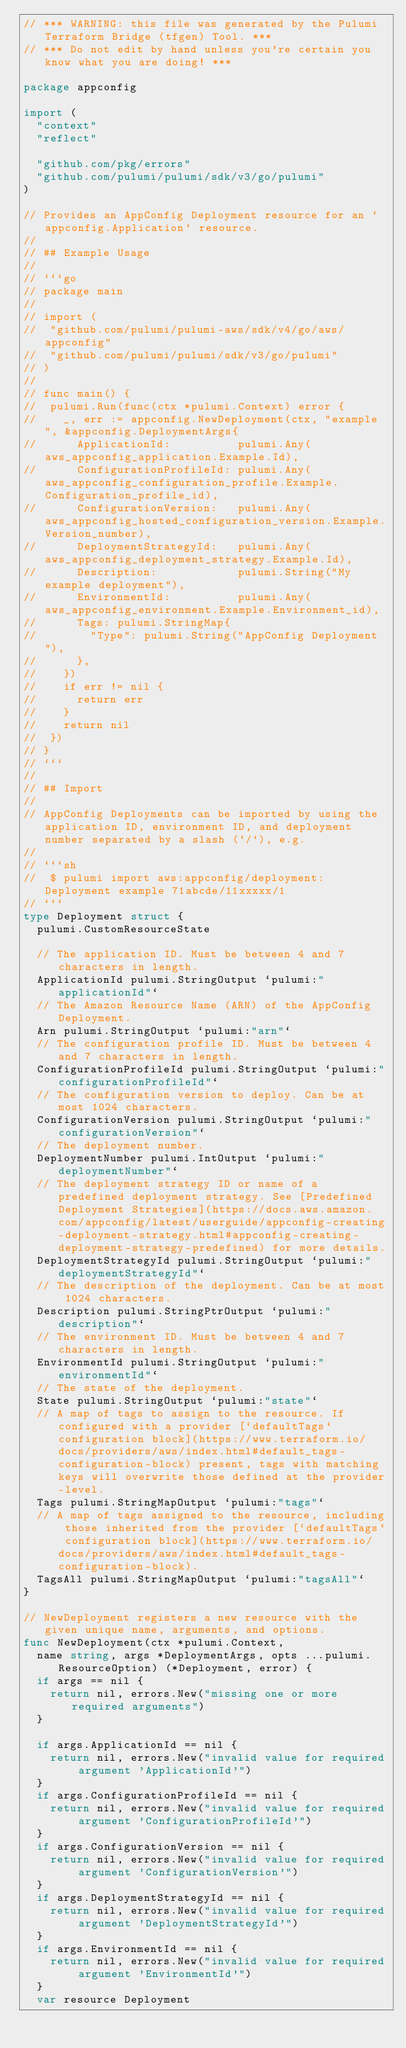Convert code to text. <code><loc_0><loc_0><loc_500><loc_500><_Go_>// *** WARNING: this file was generated by the Pulumi Terraform Bridge (tfgen) Tool. ***
// *** Do not edit by hand unless you're certain you know what you are doing! ***

package appconfig

import (
	"context"
	"reflect"

	"github.com/pkg/errors"
	"github.com/pulumi/pulumi/sdk/v3/go/pulumi"
)

// Provides an AppConfig Deployment resource for an `appconfig.Application` resource.
//
// ## Example Usage
//
// ```go
// package main
//
// import (
// 	"github.com/pulumi/pulumi-aws/sdk/v4/go/aws/appconfig"
// 	"github.com/pulumi/pulumi/sdk/v3/go/pulumi"
// )
//
// func main() {
// 	pulumi.Run(func(ctx *pulumi.Context) error {
// 		_, err := appconfig.NewDeployment(ctx, "example", &appconfig.DeploymentArgs{
// 			ApplicationId:          pulumi.Any(aws_appconfig_application.Example.Id),
// 			ConfigurationProfileId: pulumi.Any(aws_appconfig_configuration_profile.Example.Configuration_profile_id),
// 			ConfigurationVersion:   pulumi.Any(aws_appconfig_hosted_configuration_version.Example.Version_number),
// 			DeploymentStrategyId:   pulumi.Any(aws_appconfig_deployment_strategy.Example.Id),
// 			Description:            pulumi.String("My example deployment"),
// 			EnvironmentId:          pulumi.Any(aws_appconfig_environment.Example.Environment_id),
// 			Tags: pulumi.StringMap{
// 				"Type": pulumi.String("AppConfig Deployment"),
// 			},
// 		})
// 		if err != nil {
// 			return err
// 		}
// 		return nil
// 	})
// }
// ```
//
// ## Import
//
// AppConfig Deployments can be imported by using the application ID, environment ID, and deployment number separated by a slash (`/`), e.g.
//
// ```sh
//  $ pulumi import aws:appconfig/deployment:Deployment example 71abcde/11xxxxx/1
// ```
type Deployment struct {
	pulumi.CustomResourceState

	// The application ID. Must be between 4 and 7 characters in length.
	ApplicationId pulumi.StringOutput `pulumi:"applicationId"`
	// The Amazon Resource Name (ARN) of the AppConfig Deployment.
	Arn pulumi.StringOutput `pulumi:"arn"`
	// The configuration profile ID. Must be between 4 and 7 characters in length.
	ConfigurationProfileId pulumi.StringOutput `pulumi:"configurationProfileId"`
	// The configuration version to deploy. Can be at most 1024 characters.
	ConfigurationVersion pulumi.StringOutput `pulumi:"configurationVersion"`
	// The deployment number.
	DeploymentNumber pulumi.IntOutput `pulumi:"deploymentNumber"`
	// The deployment strategy ID or name of a predefined deployment strategy. See [Predefined Deployment Strategies](https://docs.aws.amazon.com/appconfig/latest/userguide/appconfig-creating-deployment-strategy.html#appconfig-creating-deployment-strategy-predefined) for more details.
	DeploymentStrategyId pulumi.StringOutput `pulumi:"deploymentStrategyId"`
	// The description of the deployment. Can be at most 1024 characters.
	Description pulumi.StringPtrOutput `pulumi:"description"`
	// The environment ID. Must be between 4 and 7 characters in length.
	EnvironmentId pulumi.StringOutput `pulumi:"environmentId"`
	// The state of the deployment.
	State pulumi.StringOutput `pulumi:"state"`
	// A map of tags to assign to the resource. If configured with a provider [`defaultTags` configuration block](https://www.terraform.io/docs/providers/aws/index.html#default_tags-configuration-block) present, tags with matching keys will overwrite those defined at the provider-level.
	Tags pulumi.StringMapOutput `pulumi:"tags"`
	// A map of tags assigned to the resource, including those inherited from the provider [`defaultTags` configuration block](https://www.terraform.io/docs/providers/aws/index.html#default_tags-configuration-block).
	TagsAll pulumi.StringMapOutput `pulumi:"tagsAll"`
}

// NewDeployment registers a new resource with the given unique name, arguments, and options.
func NewDeployment(ctx *pulumi.Context,
	name string, args *DeploymentArgs, opts ...pulumi.ResourceOption) (*Deployment, error) {
	if args == nil {
		return nil, errors.New("missing one or more required arguments")
	}

	if args.ApplicationId == nil {
		return nil, errors.New("invalid value for required argument 'ApplicationId'")
	}
	if args.ConfigurationProfileId == nil {
		return nil, errors.New("invalid value for required argument 'ConfigurationProfileId'")
	}
	if args.ConfigurationVersion == nil {
		return nil, errors.New("invalid value for required argument 'ConfigurationVersion'")
	}
	if args.DeploymentStrategyId == nil {
		return nil, errors.New("invalid value for required argument 'DeploymentStrategyId'")
	}
	if args.EnvironmentId == nil {
		return nil, errors.New("invalid value for required argument 'EnvironmentId'")
	}
	var resource Deployment</code> 